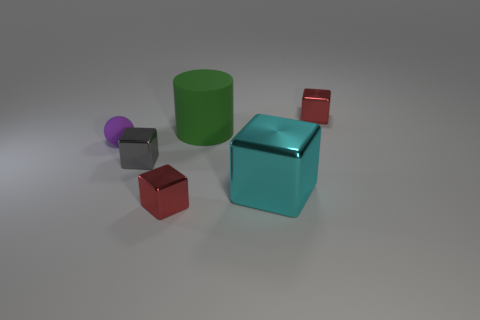Add 1 purple matte objects. How many objects exist? 7 Subtract all blocks. How many objects are left? 2 Subtract 0 brown blocks. How many objects are left? 6 Subtract all small gray shiny blocks. Subtract all tiny green metal cylinders. How many objects are left? 5 Add 2 purple rubber things. How many purple rubber things are left? 3 Add 4 tiny objects. How many tiny objects exist? 8 